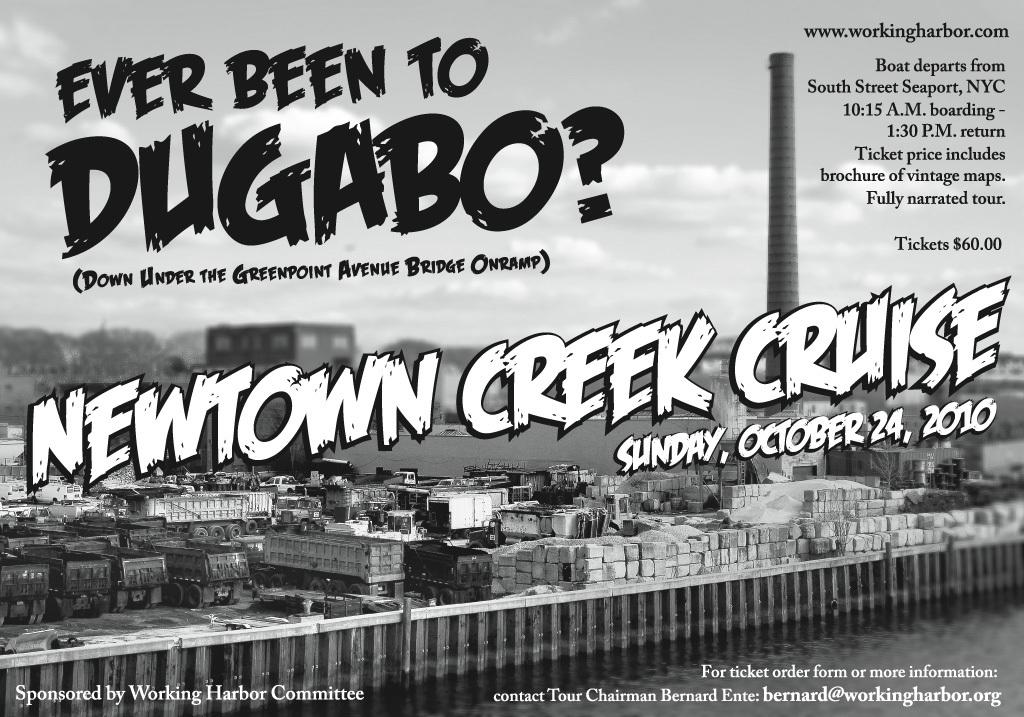<image>
Describe the image concisely. poster for the newtown creek cruise on october 24, 2010 showing b&w photo of port and a smokestack 